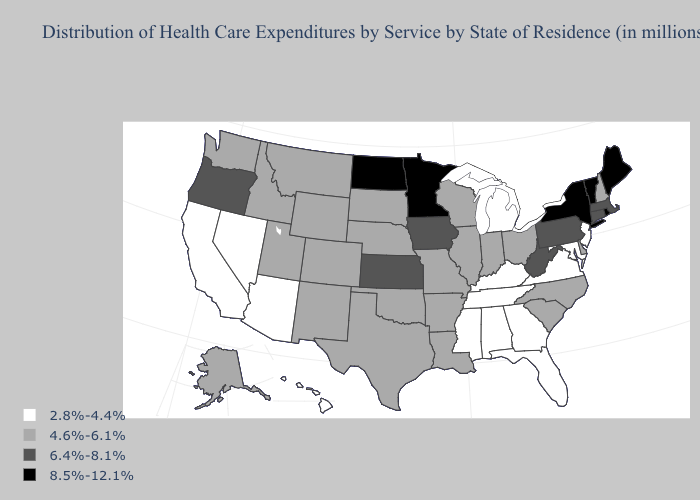Name the states that have a value in the range 2.8%-4.4%?
Be succinct. Alabama, Arizona, California, Florida, Georgia, Hawaii, Kentucky, Maryland, Michigan, Mississippi, Nevada, New Jersey, Tennessee, Virginia. Among the states that border Iowa , which have the highest value?
Short answer required. Minnesota. Does Nebraska have the highest value in the USA?
Keep it brief. No. What is the value of Connecticut?
Short answer required. 6.4%-8.1%. Does New Hampshire have a lower value than South Carolina?
Write a very short answer. No. Does Tennessee have the same value as Florida?
Keep it brief. Yes. Name the states that have a value in the range 2.8%-4.4%?
Quick response, please. Alabama, Arizona, California, Florida, Georgia, Hawaii, Kentucky, Maryland, Michigan, Mississippi, Nevada, New Jersey, Tennessee, Virginia. What is the value of Missouri?
Give a very brief answer. 4.6%-6.1%. Among the states that border Kansas , which have the highest value?
Write a very short answer. Colorado, Missouri, Nebraska, Oklahoma. What is the highest value in the USA?
Be succinct. 8.5%-12.1%. What is the lowest value in states that border New Jersey?
Short answer required. 4.6%-6.1%. Is the legend a continuous bar?
Give a very brief answer. No. What is the lowest value in states that border Arizona?
Short answer required. 2.8%-4.4%. Among the states that border Indiana , which have the lowest value?
Be succinct. Kentucky, Michigan. Among the states that border North Carolina , which have the lowest value?
Be succinct. Georgia, Tennessee, Virginia. 